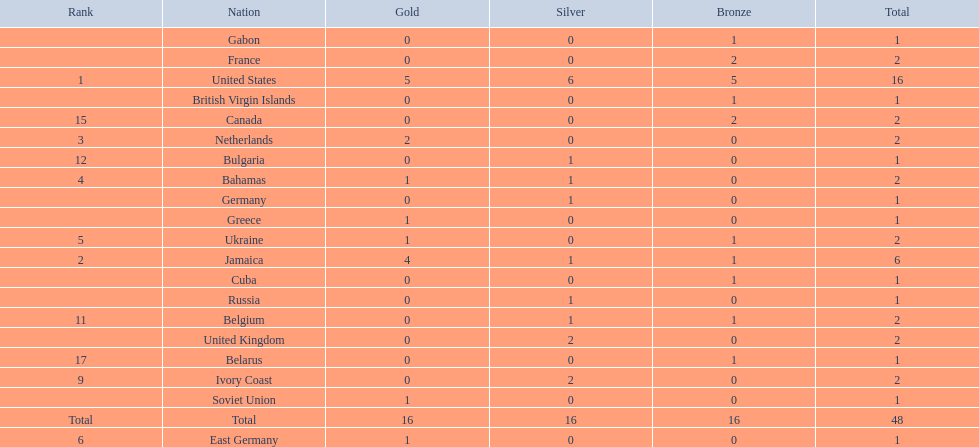What number of nations received 1 medal? 10. 